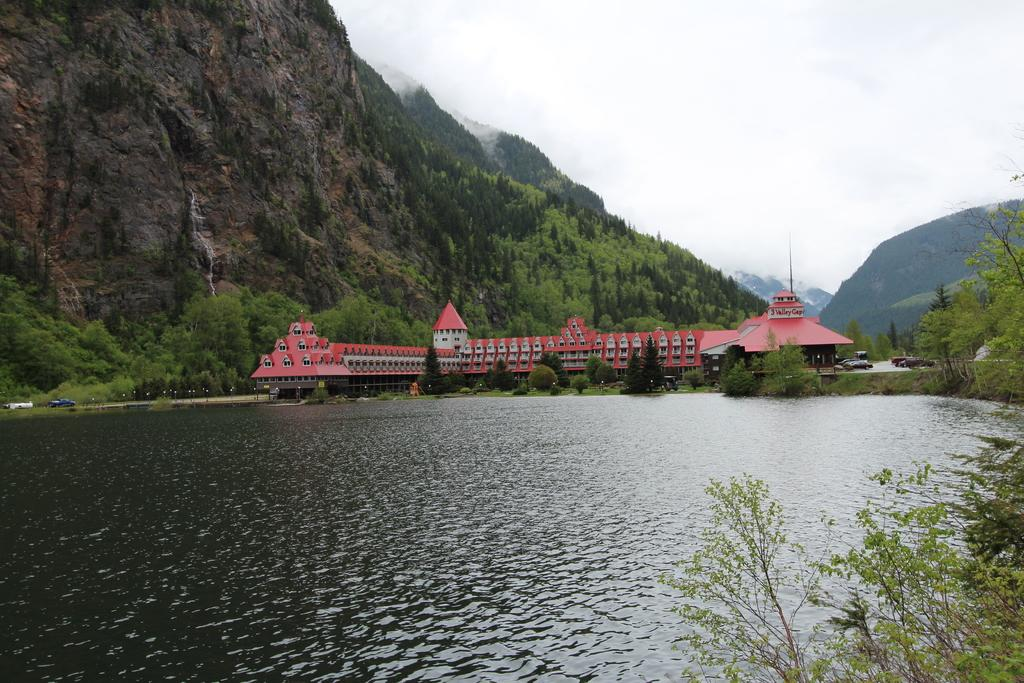What type of natural feature is the main subject of the image? There is a lake in the image. What else can be seen in the sky in the image? The sky is visible in the image. What is the landscape feature located behind the lake? There is a hill in the image. What type of vegetation is present in the image? Trees are present in the image. What scent can be detected from the image? There is no scent present in the image, as it is a visual representation. 